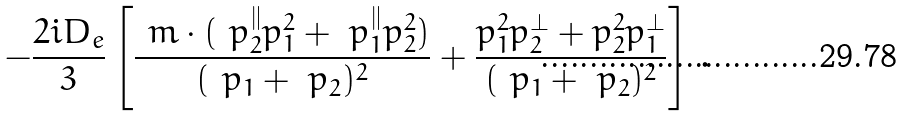Convert formula to latex. <formula><loc_0><loc_0><loc_500><loc_500>- \frac { 2 i D _ { e } } { 3 } \left [ \frac { \ m \cdot ( \ p ^ { \| } _ { 2 } p _ { 1 } ^ { 2 } + \ p ^ { \| } _ { 1 } p _ { 2 } ^ { 2 } ) } { ( \ p _ { 1 } + \ p _ { 2 } ) ^ { 2 } } + \frac { p _ { 1 } ^ { 2 } p ^ { \perp } _ { 2 } + p _ { 2 } ^ { 2 } p ^ { \perp } _ { 1 } } { ( \ p _ { 1 } + \ p _ { 2 } ) ^ { 2 } } \right ] \, .</formula> 